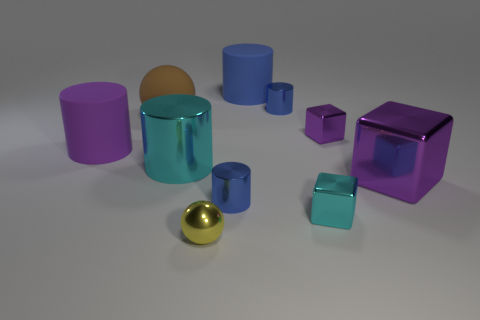Subtract all small metallic cylinders. How many cylinders are left? 3 Subtract all brown balls. How many balls are left? 1 Subtract all spheres. How many objects are left? 8 Add 7 big cylinders. How many big cylinders are left? 10 Add 3 purple cylinders. How many purple cylinders exist? 4 Subtract 3 blue cylinders. How many objects are left? 7 Subtract 2 blocks. How many blocks are left? 1 Subtract all red cubes. Subtract all yellow cylinders. How many cubes are left? 3 Subtract all gray balls. How many purple blocks are left? 2 Subtract all small green metallic blocks. Subtract all tiny cyan objects. How many objects are left? 9 